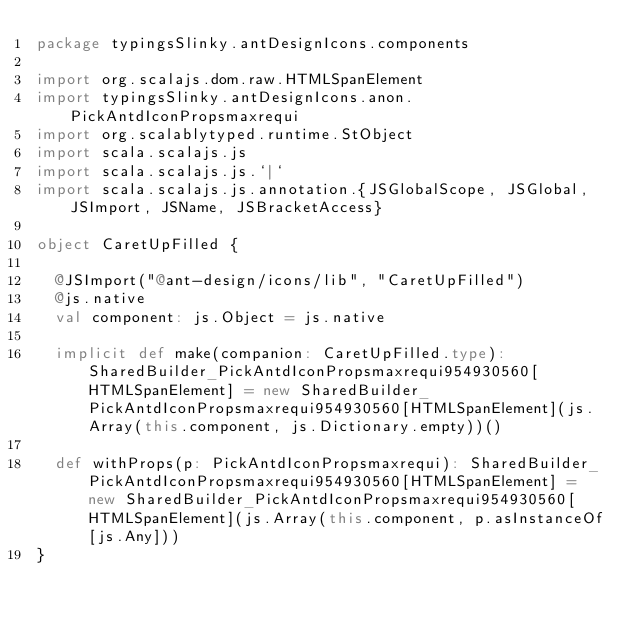Convert code to text. <code><loc_0><loc_0><loc_500><loc_500><_Scala_>package typingsSlinky.antDesignIcons.components

import org.scalajs.dom.raw.HTMLSpanElement
import typingsSlinky.antDesignIcons.anon.PickAntdIconPropsmaxrequi
import org.scalablytyped.runtime.StObject
import scala.scalajs.js
import scala.scalajs.js.`|`
import scala.scalajs.js.annotation.{JSGlobalScope, JSGlobal, JSImport, JSName, JSBracketAccess}

object CaretUpFilled {
  
  @JSImport("@ant-design/icons/lib", "CaretUpFilled")
  @js.native
  val component: js.Object = js.native
  
  implicit def make(companion: CaretUpFilled.type): SharedBuilder_PickAntdIconPropsmaxrequi954930560[HTMLSpanElement] = new SharedBuilder_PickAntdIconPropsmaxrequi954930560[HTMLSpanElement](js.Array(this.component, js.Dictionary.empty))()
  
  def withProps(p: PickAntdIconPropsmaxrequi): SharedBuilder_PickAntdIconPropsmaxrequi954930560[HTMLSpanElement] = new SharedBuilder_PickAntdIconPropsmaxrequi954930560[HTMLSpanElement](js.Array(this.component, p.asInstanceOf[js.Any]))
}
</code> 